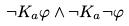Convert formula to latex. <formula><loc_0><loc_0><loc_500><loc_500>\neg K _ { a } \varphi \wedge \neg K _ { a } \neg \varphi</formula> 